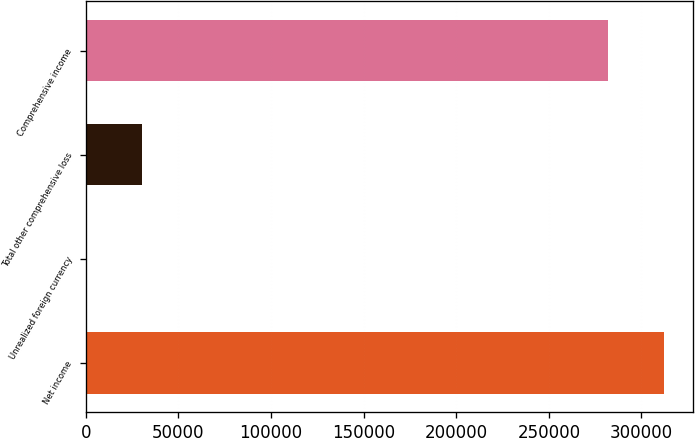Convert chart to OTSL. <chart><loc_0><loc_0><loc_500><loc_500><bar_chart><fcel>Net income<fcel>Unrealized foreign currency<fcel>Total other comprehensive loss<fcel>Comprehensive income<nl><fcel>312268<fcel>176<fcel>30591.4<fcel>281853<nl></chart> 